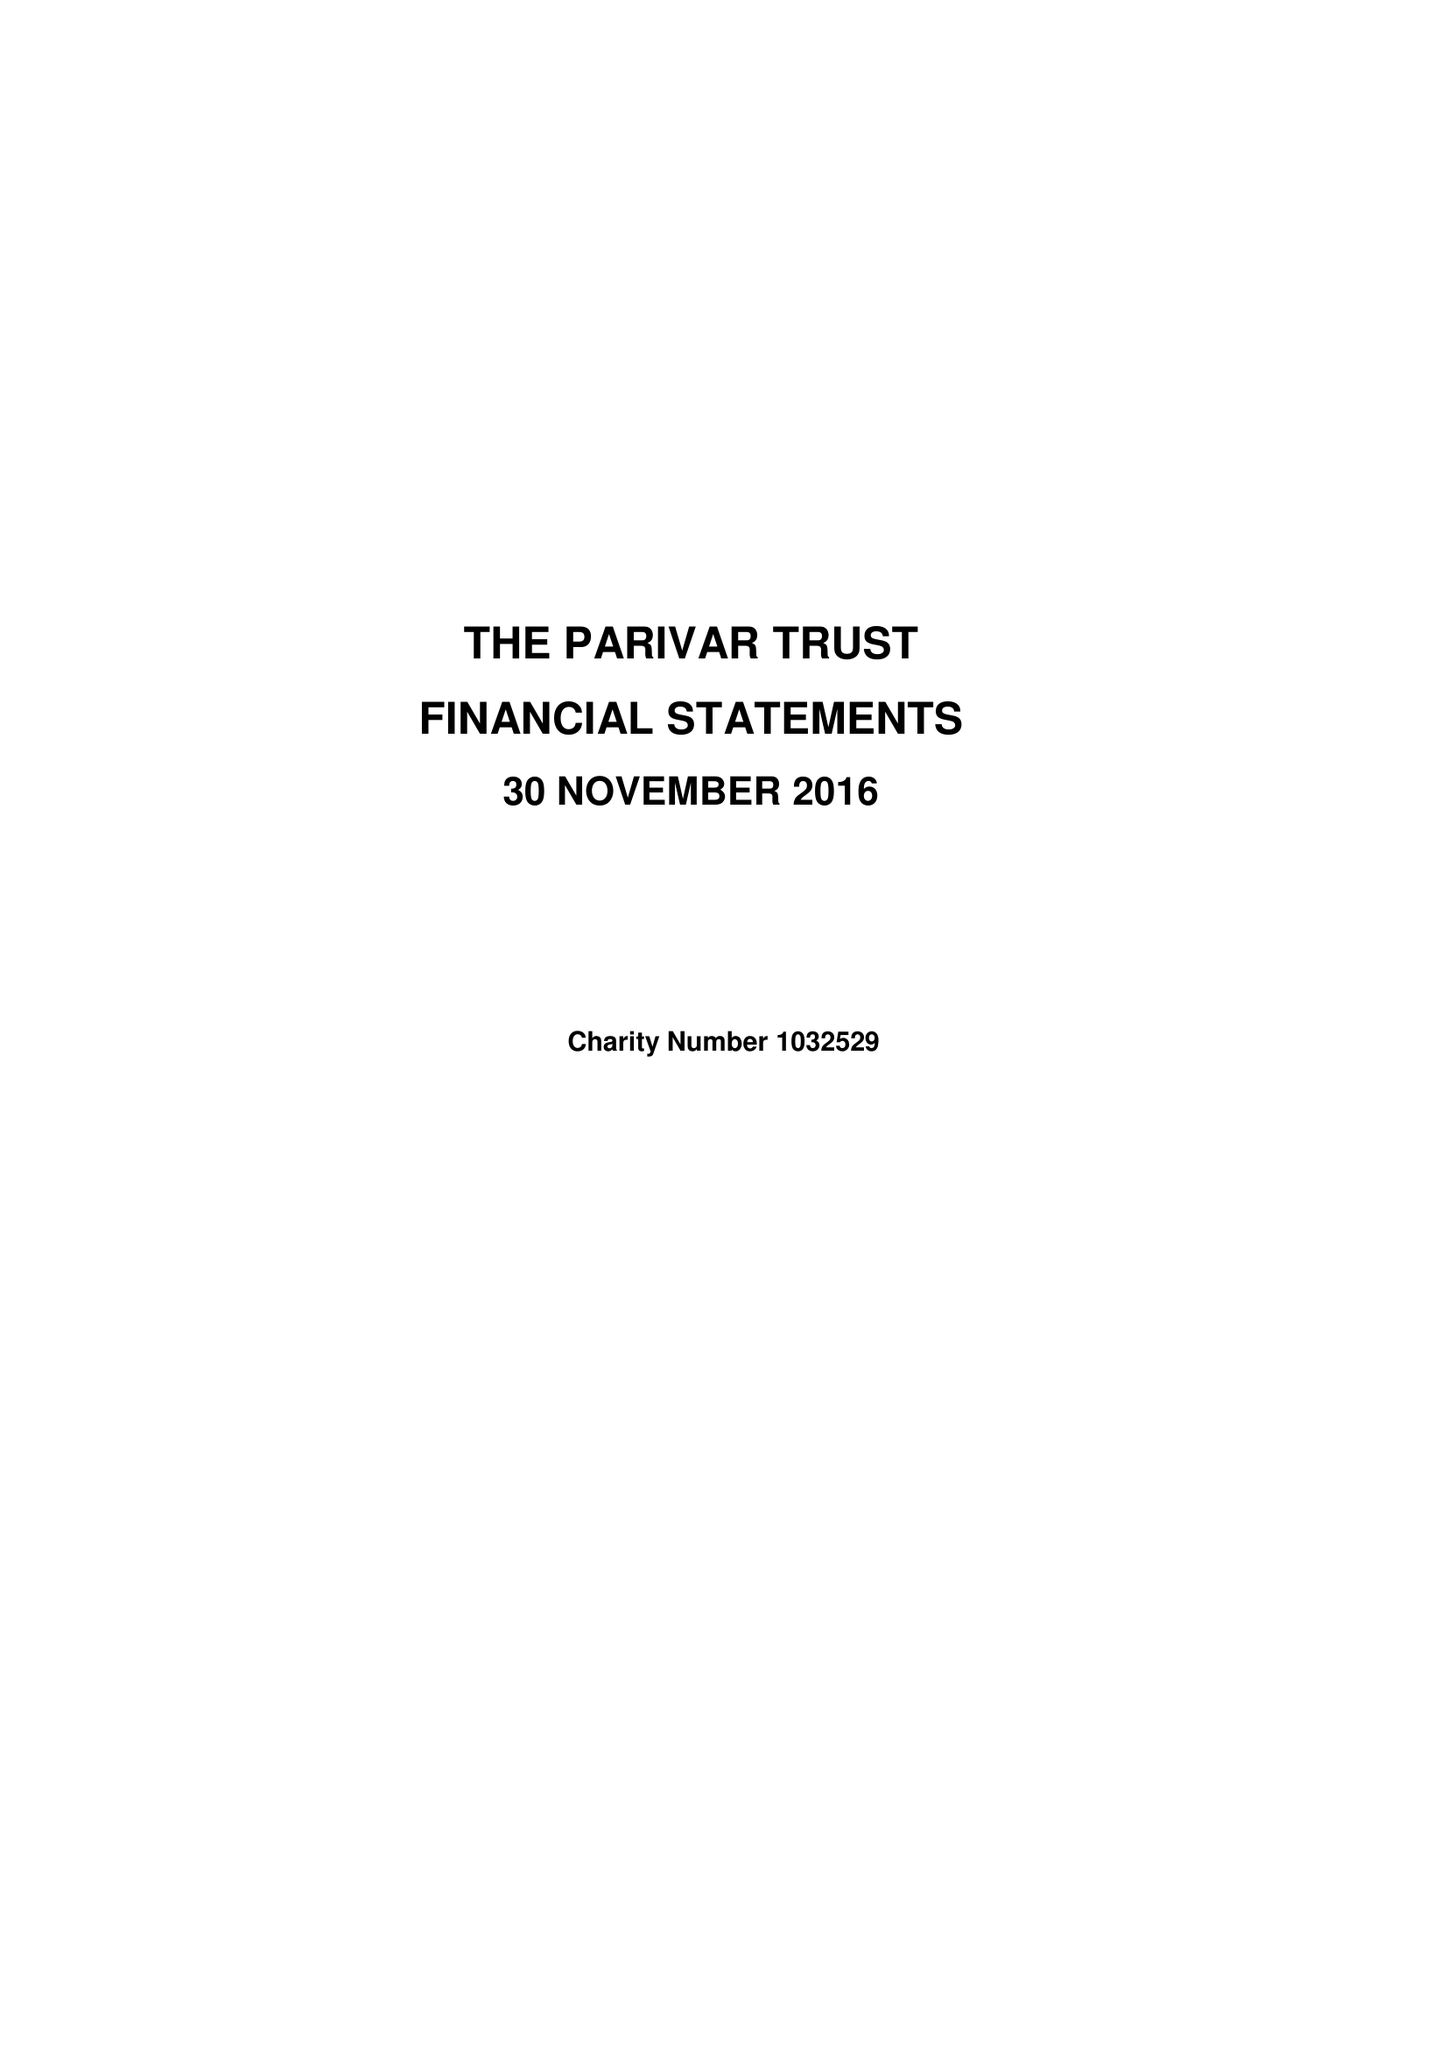What is the value for the spending_annually_in_british_pounds?
Answer the question using a single word or phrase. 71464.00 